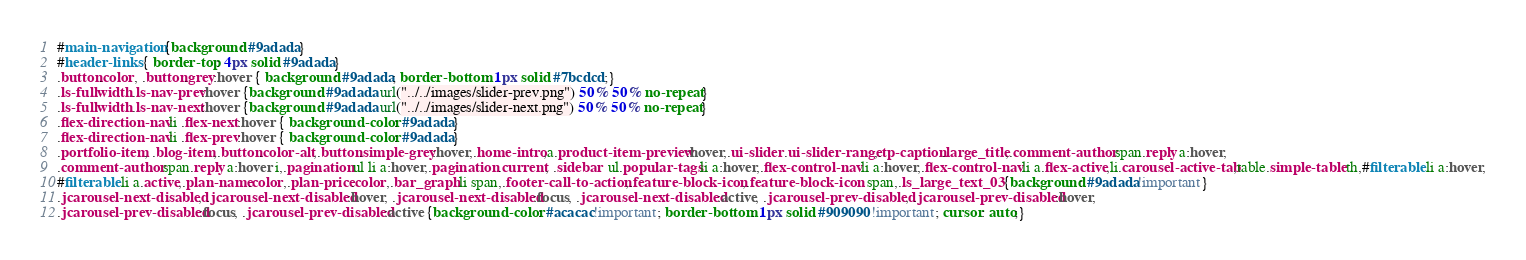<code> <loc_0><loc_0><loc_500><loc_500><_CSS_>#main-navigation {background: #9adada}
#header-links { border-top: 4px solid #9adada}
.button.color, .button.grey:hover { background: #9adada; border-bottom: 1px solid #7bcdcd;}
.ls-fullwidth .ls-nav-prev:hover {background: #9adada url("../../images/slider-prev.png") 50% 50% no-repeat}
.ls-fullwidth .ls-nav-next:hover {background: #9adada url("../../images/slider-next.png") 50% 50% no-repeat}
.flex-direction-nav li .flex-next:hover { background-color: #9adada}
.flex-direction-nav li .flex-prev:hover { background-color: #9adada} 
.portfolio-item, .blog-item,.button.color-alt,.button.simple-grey:hover,.home-intro,a.product-item-preview:hover,.ui-slider .ui-slider-range,.tp-caption.large_title,.comment-author span.reply a:hover,
.comment-author span.reply a:hover i,.pagination ul li a:hover,.pagination .current, .sidebar  ul.popular-tags li a:hover,.flex-control-nav li a:hover,.flex-control-nav li a.flex-active,li.carousel-active-tab,table.simple-table th,#filterable li a:hover,
#filterable li a.active,.plan-name.color,.plan-price.color,.bar_graph li span,.footer-call-to-action,.feature-block-icon,.feature-block-icon  span,.ls_large_text_03 {background: #9adada!important}
.jcarousel-next-disabled, .jcarousel-next-disabled:hover, .jcarousel-next-disabled:focus, .jcarousel-next-disabled:active, .jcarousel-prev-disabled, .jcarousel-prev-disabled:hover, 
.jcarousel-prev-disabled:focus, .jcarousel-prev-disabled:active {background-color: #acacac!important; border-bottom: 1px solid #909090!important; cursor: auto;}</code> 